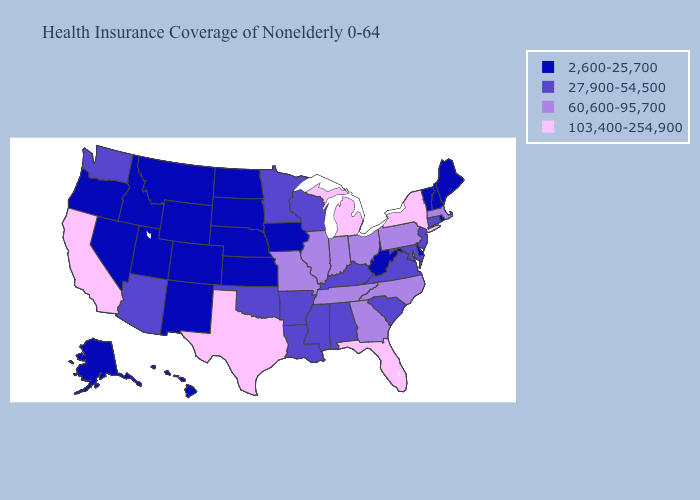Among the states that border Texas , which have the highest value?
Quick response, please. Arkansas, Louisiana, Oklahoma. Does Wisconsin have the lowest value in the MidWest?
Write a very short answer. No. What is the lowest value in the USA?
Quick response, please. 2,600-25,700. Name the states that have a value in the range 60,600-95,700?
Short answer required. Georgia, Illinois, Indiana, Massachusetts, Missouri, North Carolina, Ohio, Pennsylvania, Tennessee. Among the states that border Idaho , does Washington have the lowest value?
Concise answer only. No. How many symbols are there in the legend?
Short answer required. 4. What is the value of North Carolina?
Short answer required. 60,600-95,700. How many symbols are there in the legend?
Concise answer only. 4. Name the states that have a value in the range 27,900-54,500?
Answer briefly. Alabama, Arizona, Arkansas, Connecticut, Kentucky, Louisiana, Maryland, Minnesota, Mississippi, New Jersey, Oklahoma, South Carolina, Virginia, Washington, Wisconsin. Among the states that border Alabama , which have the highest value?
Short answer required. Florida. Name the states that have a value in the range 60,600-95,700?
Quick response, please. Georgia, Illinois, Indiana, Massachusetts, Missouri, North Carolina, Ohio, Pennsylvania, Tennessee. What is the value of Idaho?
Answer briefly. 2,600-25,700. Among the states that border Georgia , which have the lowest value?
Keep it brief. Alabama, South Carolina. Among the states that border Indiana , which have the lowest value?
Concise answer only. Kentucky. Name the states that have a value in the range 27,900-54,500?
Give a very brief answer. Alabama, Arizona, Arkansas, Connecticut, Kentucky, Louisiana, Maryland, Minnesota, Mississippi, New Jersey, Oklahoma, South Carolina, Virginia, Washington, Wisconsin. 